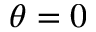Convert formula to latex. <formula><loc_0><loc_0><loc_500><loc_500>\theta = 0</formula> 